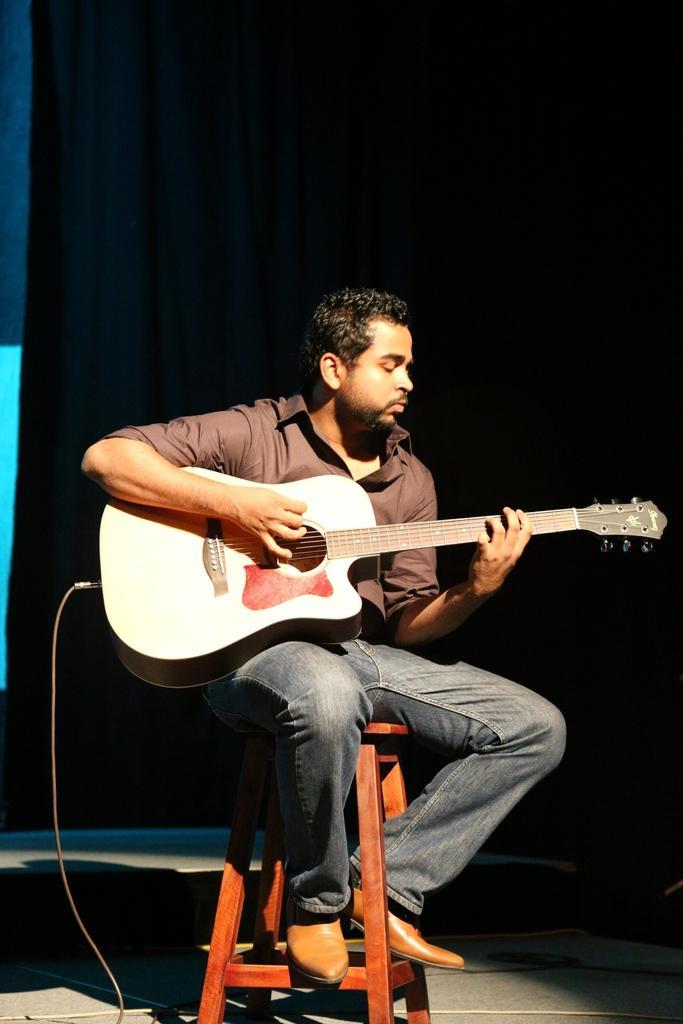Please provide a concise description of this image. The picture is taken on a stage. In the center of the picture there is a man sitting on a stool and playing guitar. In the background there is a black curtain. In the foreground there is a cable. 